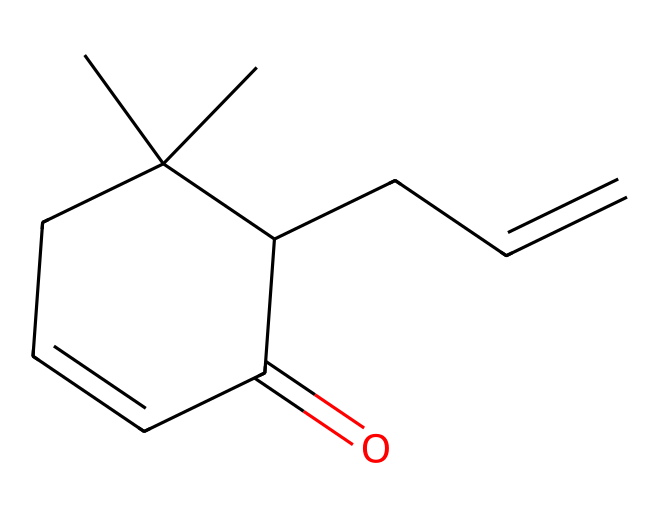How many carbon atoms are in jasmone? The SMILES representation shows multiple carbon atoms, and by counting the "C" symbols in the structure, we can identify that there are ten carbon atoms.
Answer: ten What is the functional group present in jasmone? The presence of the "C=O" notation in the SMILES indicates that this molecule features a carbonyl group, characteristic of ketones.
Answer: carbonyl What is the degree of saturation for jasmone? By counting the number of rings and double bonds in the structure, we can determine the degree of saturation. The presence of one ring and several double bonds indicates a high degree of saturation, which in this case is 10.
Answer: 10 How many double bonds are present in jasmone? Examining the structure reveals that there are two double bonds, indicated by "C=C" in the SMILES, that contribute to the molecule's unsaturation.
Answer: two Is jasmone a ketone or an aldehyde? In the structure, the ketone functionality is identified because the carbonyl (C=O) is bonded to two carbon atoms, characteristic of a ketone rather than an aldehyde, which would bond to a hydrogen.
Answer: ketone Which part of the molecule contributes to its floral scent? The cyclohexene ring along with the surrounding substituents in the structure contributes to the overall aroma, but specifically, the branched alkyl groups are often related to the floral scent.
Answer: cyclohexene ring What is the molecular formula for jasmone? By using the provided SMILES, we can deduce the molecular formula by identifying the total number of each atom type present. In this case, there are 10 carbons, 14 hydrogens, and 1 oxygen, yielding the formula C10H14O.
Answer: C10H14O 